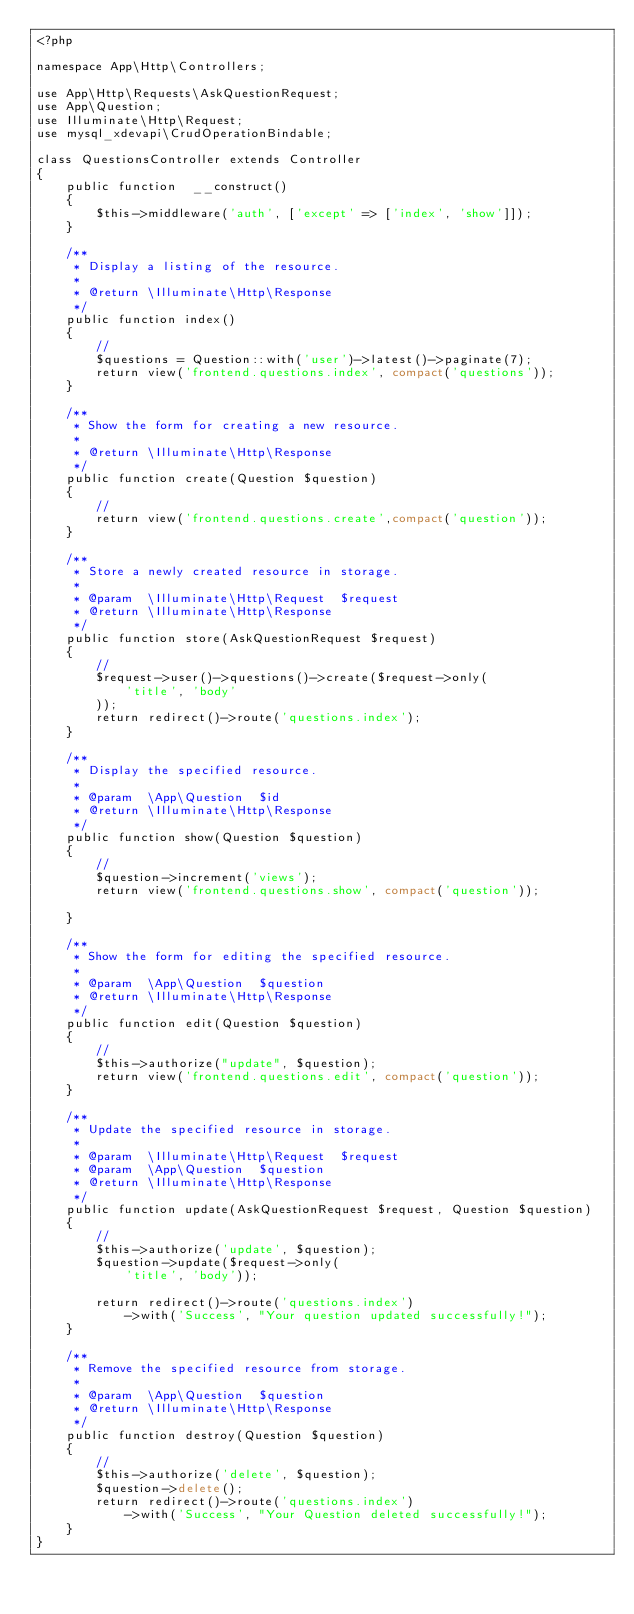Convert code to text. <code><loc_0><loc_0><loc_500><loc_500><_PHP_><?php

namespace App\Http\Controllers;

use App\Http\Requests\AskQuestionRequest;
use App\Question;
use Illuminate\Http\Request;
use mysql_xdevapi\CrudOperationBindable;

class QuestionsController extends Controller
{
    public function  __construct()
    {
        $this->middleware('auth', ['except' => ['index', 'show']]);
    }

    /**
     * Display a listing of the resource.
     *
     * @return \Illuminate\Http\Response
     */
    public function index()
    {
        //
        $questions = Question::with('user')->latest()->paginate(7);
        return view('frontend.questions.index', compact('questions'));
    }

    /**
     * Show the form for creating a new resource.
     *
     * @return \Illuminate\Http\Response
     */
    public function create(Question $question)
    {
        //
        return view('frontend.questions.create',compact('question'));
    }

    /**
     * Store a newly created resource in storage.
     *
     * @param  \Illuminate\Http\Request  $request
     * @return \Illuminate\Http\Response
     */
    public function store(AskQuestionRequest $request)
    {
        //
        $request->user()->questions()->create($request->only(
            'title', 'body'
        ));
        return redirect()->route('questions.index');
    }

    /**
     * Display the specified resource.
     *
     * @param  \App\Question  $id
     * @return \Illuminate\Http\Response
     */
    public function show(Question $question)
    {
        //
        $question->increment('views');
        return view('frontend.questions.show', compact('question'));

    }

    /**
     * Show the form for editing the specified resource.
     *
     * @param  \App\Question  $question
     * @return \Illuminate\Http\Response
     */
    public function edit(Question $question)
    {
        //
        $this->authorize("update", $question);
        return view('frontend.questions.edit', compact('question'));
    }

    /**
     * Update the specified resource in storage.
     *
     * @param  \Illuminate\Http\Request  $request
     * @param  \App\Question  $question
     * @return \Illuminate\Http\Response
     */
    public function update(AskQuestionRequest $request, Question $question)
    {
        //
        $this->authorize('update', $question);
        $question->update($request->only(
            'title', 'body'));

        return redirect()->route('questions.index')
            ->with('Success', "Your question updated successfully!");
    }

    /**
     * Remove the specified resource from storage.
     *
     * @param  \App\Question  $question
     * @return \Illuminate\Http\Response
     */
    public function destroy(Question $question)
    {
        //
        $this->authorize('delete', $question);
        $question->delete();
        return redirect()->route('questions.index')
            ->with('Success', "Your Question deleted successfully!");
    }
}
</code> 